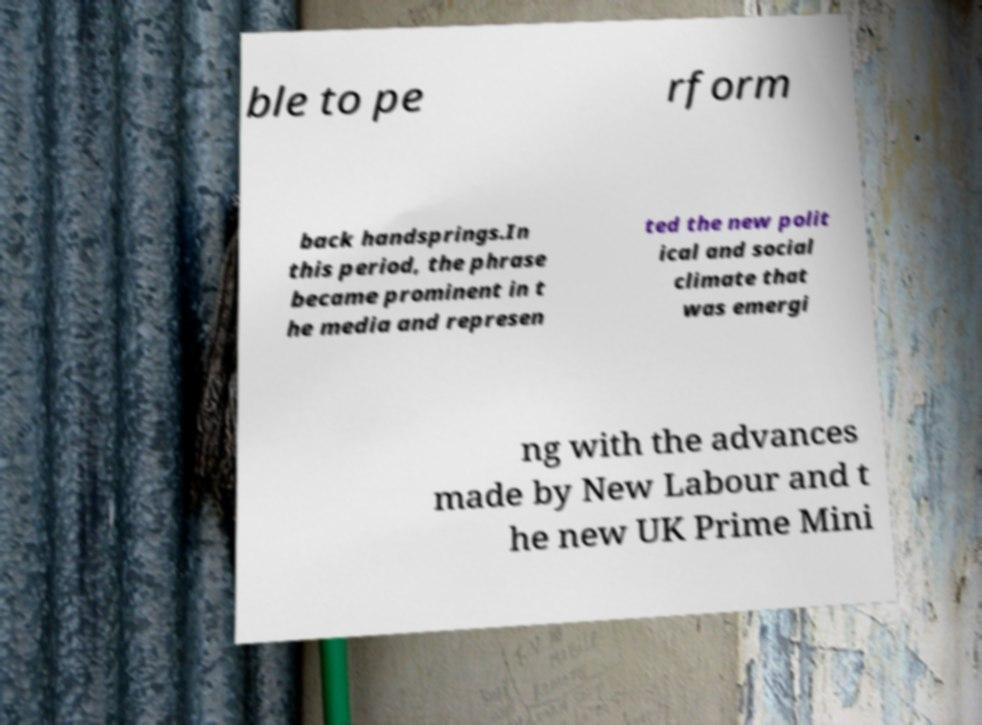Can you read and provide the text displayed in the image?This photo seems to have some interesting text. Can you extract and type it out for me? ble to pe rform back handsprings.In this period, the phrase became prominent in t he media and represen ted the new polit ical and social climate that was emergi ng with the advances made by New Labour and t he new UK Prime Mini 